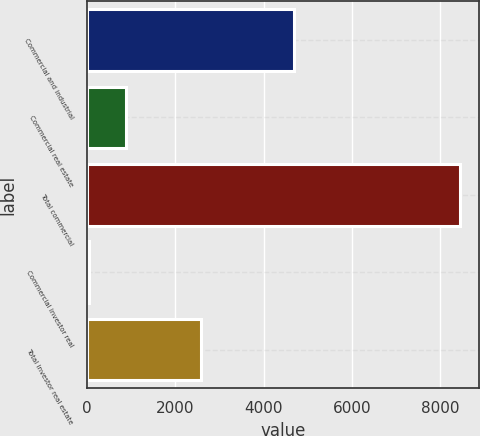Convert chart. <chart><loc_0><loc_0><loc_500><loc_500><bar_chart><fcel>Commercial and industrial<fcel>Commercial real estate<fcel>Total commercial<fcel>Commercial investor real<fcel>Total investor real estate<nl><fcel>4678.4<fcel>888.4<fcel>8452<fcel>48<fcel>2569.2<nl></chart> 